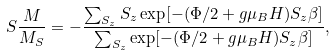<formula> <loc_0><loc_0><loc_500><loc_500>S \frac { M } { M _ { S } } = - \frac { \sum _ { S _ { z } } S _ { z } \exp [ - ( \Phi / 2 + g \mu _ { B } H ) S _ { z } \beta ] } { \sum _ { S _ { z } } \exp [ - ( \Phi / 2 + g \mu _ { B } H ) S _ { z } \beta ] } ,</formula> 